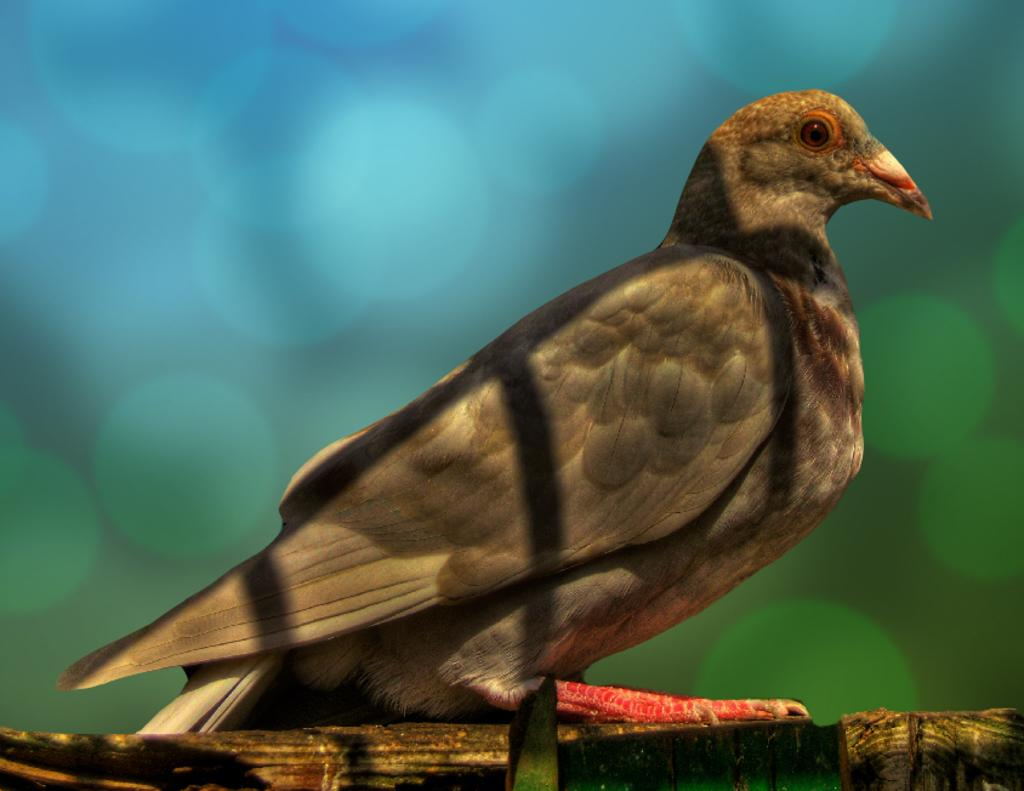What type of animal is in the image? There is a bird in the image. Can you describe the colors of the bird? The bird has brown, black, cream, orange, and red colors. What is the bird sitting on in the image? The bird is on a wooden object. How would you describe the background of the image? The background of the image is blurry, and the colors are blue and brown. What reason does the bird have for holding a bucket in the image? There is no bucket present in the image, so the bird cannot be holding one. 